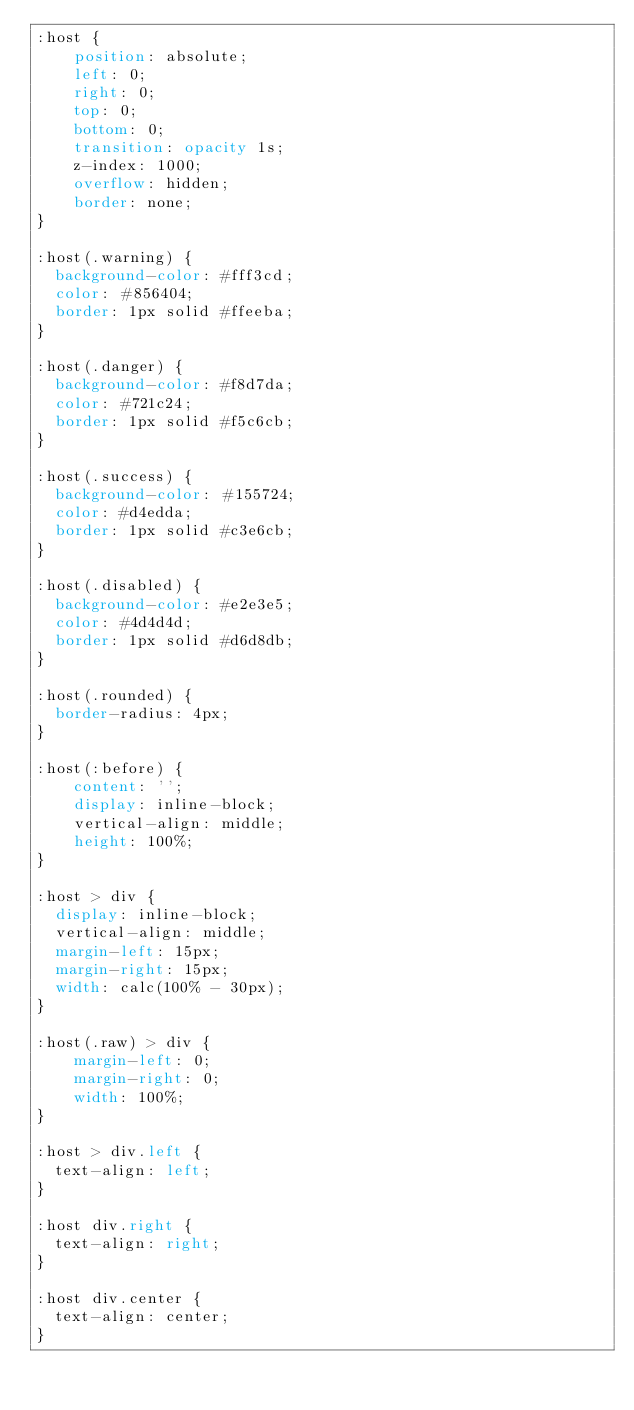<code> <loc_0><loc_0><loc_500><loc_500><_CSS_>:host {
    position: absolute;
    left: 0;
    right: 0;
    top: 0;
    bottom: 0;
    transition: opacity 1s;
    z-index: 1000;
    overflow: hidden;
    border: none;
}

:host(.warning) {
  background-color: #fff3cd;
  color: #856404;
  border: 1px solid #ffeeba;
}

:host(.danger) {
  background-color: #f8d7da;
  color: #721c24;
  border: 1px solid #f5c6cb;
}

:host(.success) {
  background-color: #155724;
  color: #d4edda;
  border: 1px solid #c3e6cb;
}

:host(.disabled) {
  background-color: #e2e3e5;
  color: #4d4d4d;
  border: 1px solid #d6d8db;
}

:host(.rounded) {
  border-radius: 4px;
}

:host(:before) {
    content: '';
    display: inline-block;
    vertical-align: middle;
    height: 100%;
}

:host > div {
  display: inline-block;
  vertical-align: middle;
  margin-left: 15px;
  margin-right: 15px;
  width: calc(100% - 30px);
}

:host(.raw) > div {
    margin-left: 0;
    margin-right: 0;
    width: 100%;
}

:host > div.left {
  text-align: left;
}

:host div.right {
  text-align: right;
}

:host div.center {
  text-align: center;
}


</code> 